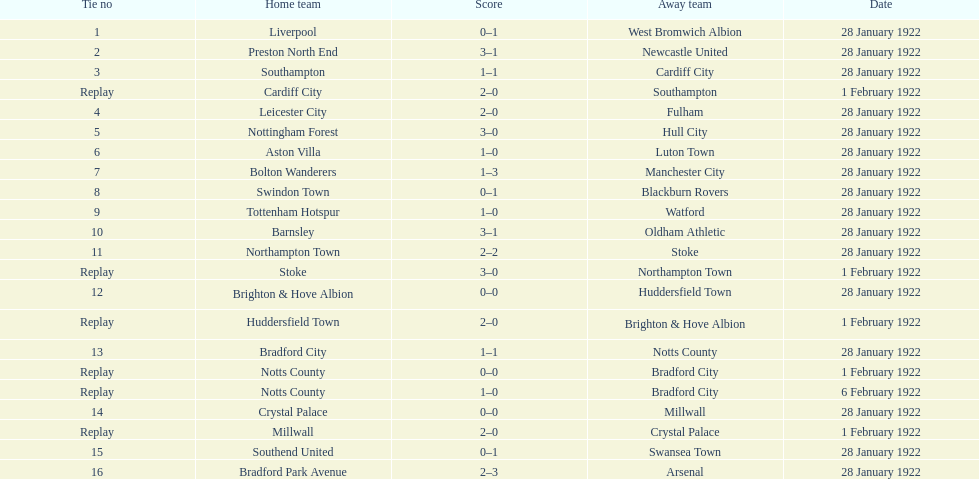Could you parse the entire table? {'header': ['Tie no', 'Home team', 'Score', 'Away team', 'Date'], 'rows': [['1', 'Liverpool', '0–1', 'West Bromwich Albion', '28 January 1922'], ['2', 'Preston North End', '3–1', 'Newcastle United', '28 January 1922'], ['3', 'Southampton', '1–1', 'Cardiff City', '28 January 1922'], ['Replay', 'Cardiff City', '2–0', 'Southampton', '1 February 1922'], ['4', 'Leicester City', '2–0', 'Fulham', '28 January 1922'], ['5', 'Nottingham Forest', '3–0', 'Hull City', '28 January 1922'], ['6', 'Aston Villa', '1–0', 'Luton Town', '28 January 1922'], ['7', 'Bolton Wanderers', '1–3', 'Manchester City', '28 January 1922'], ['8', 'Swindon Town', '0–1', 'Blackburn Rovers', '28 January 1922'], ['9', 'Tottenham Hotspur', '1–0', 'Watford', '28 January 1922'], ['10', 'Barnsley', '3–1', 'Oldham Athletic', '28 January 1922'], ['11', 'Northampton Town', '2–2', 'Stoke', '28 January 1922'], ['Replay', 'Stoke', '3–0', 'Northampton Town', '1 February 1922'], ['12', 'Brighton & Hove Albion', '0–0', 'Huddersfield Town', '28 January 1922'], ['Replay', 'Huddersfield Town', '2–0', 'Brighton & Hove Albion', '1 February 1922'], ['13', 'Bradford City', '1–1', 'Notts County', '28 January 1922'], ['Replay', 'Notts County', '0–0', 'Bradford City', '1 February 1922'], ['Replay', 'Notts County', '1–0', 'Bradford City', '6 February 1922'], ['14', 'Crystal Palace', '0–0', 'Millwall', '28 January 1922'], ['Replay', 'Millwall', '2–0', 'Crystal Palace', '1 February 1922'], ['15', 'Southend United', '0–1', 'Swansea Town', '28 January 1922'], ['16', 'Bradford Park Avenue', '2–3', 'Arsenal', '28 January 1922']]} What home team had the same score as aston villa on january 28th, 1922? Tottenham Hotspur. 